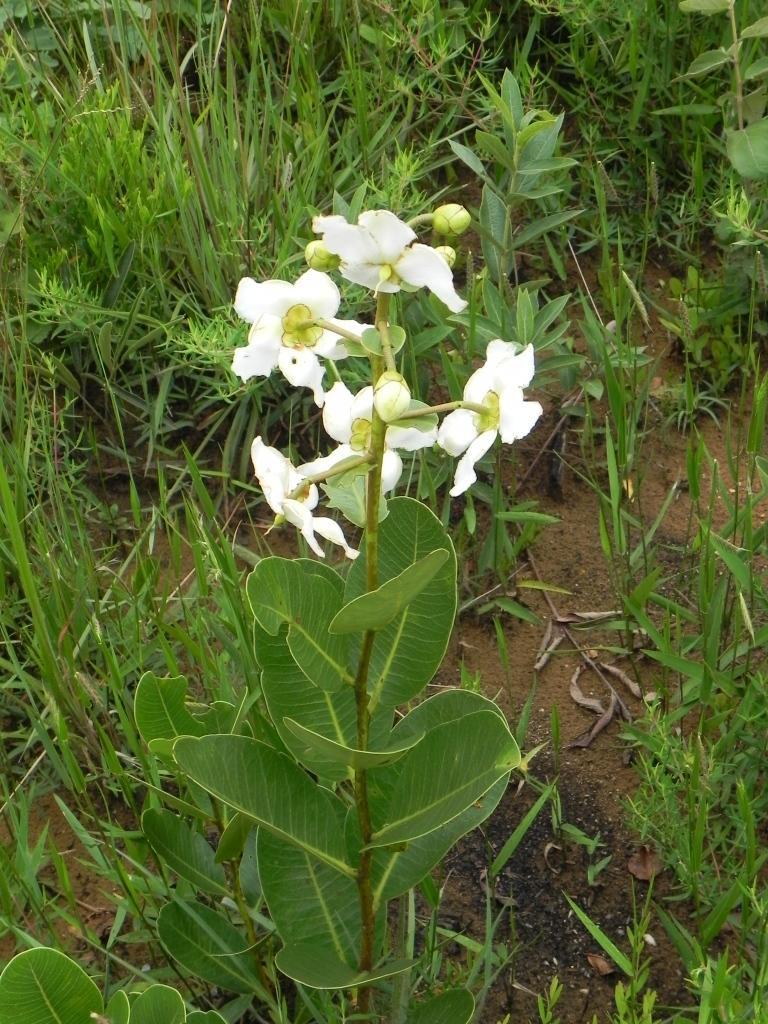What type of plant is in the image? There is a plant in the image. What stage of growth are the plant's buds in? The plant has buds. What additional features can be seen on the plant? The plant has flowers. What color are the flowers on the plant? The flowers are white. What type of vegetation is visible in the background of the image? There is grass in the background of the image. What type of surface is visible in the background of the image? There is soil visible in the background of the image. How many fifths are visible in the image? There is no reference to a "fifth" in the image, as it features a plant with buds and flowers, grass, and soil in the background. 